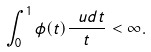Convert formula to latex. <formula><loc_0><loc_0><loc_500><loc_500>\int _ { 0 } ^ { 1 } \phi ( t ) \frac { \ u d t } { t } < \infty .</formula> 